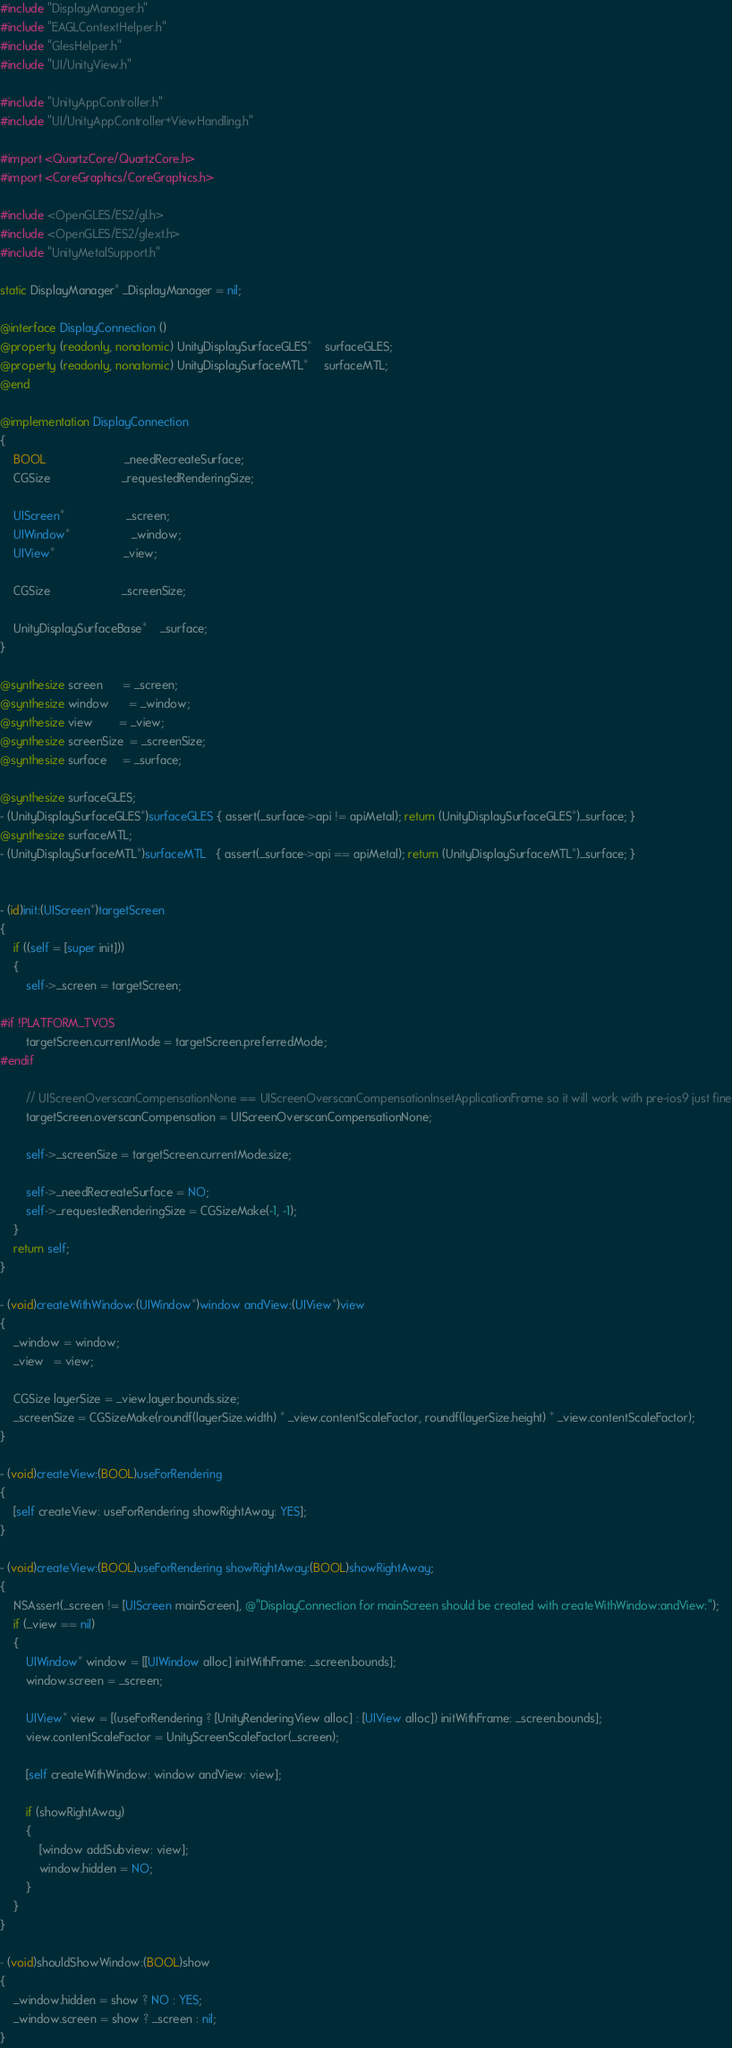<code> <loc_0><loc_0><loc_500><loc_500><_ObjectiveC_>#include "DisplayManager.h"
#include "EAGLContextHelper.h"
#include "GlesHelper.h"
#include "UI/UnityView.h"

#include "UnityAppController.h"
#include "UI/UnityAppController+ViewHandling.h"

#import <QuartzCore/QuartzCore.h>
#import <CoreGraphics/CoreGraphics.h>

#include <OpenGLES/ES2/gl.h>
#include <OpenGLES/ES2/glext.h>
#include "UnityMetalSupport.h"

static DisplayManager* _DisplayManager = nil;

@interface DisplayConnection ()
@property (readonly, nonatomic) UnityDisplaySurfaceGLES*    surfaceGLES;
@property (readonly, nonatomic) UnityDisplaySurfaceMTL*     surfaceMTL;
@end

@implementation DisplayConnection
{
    BOOL                        _needRecreateSurface;
    CGSize                      _requestedRenderingSize;

    UIScreen*                   _screen;
    UIWindow*                   _window;
    UIView*                     _view;

    CGSize                      _screenSize;

    UnityDisplaySurfaceBase*    _surface;
}

@synthesize screen      = _screen;
@synthesize window      = _window;
@synthesize view        = _view;
@synthesize screenSize  = _screenSize;
@synthesize surface     = _surface;

@synthesize surfaceGLES;
- (UnityDisplaySurfaceGLES*)surfaceGLES { assert(_surface->api != apiMetal); return (UnityDisplaySurfaceGLES*)_surface; }
@synthesize surfaceMTL;
- (UnityDisplaySurfaceMTL*)surfaceMTL   { assert(_surface->api == apiMetal); return (UnityDisplaySurfaceMTL*)_surface; }


- (id)init:(UIScreen*)targetScreen
{
    if ((self = [super init]))
    {
        self->_screen = targetScreen;

#if !PLATFORM_TVOS
        targetScreen.currentMode = targetScreen.preferredMode;
#endif

        // UIScreenOverscanCompensationNone == UIScreenOverscanCompensationInsetApplicationFrame so it will work with pre-ios9 just fine
        targetScreen.overscanCompensation = UIScreenOverscanCompensationNone;

        self->_screenSize = targetScreen.currentMode.size;

        self->_needRecreateSurface = NO;
        self->_requestedRenderingSize = CGSizeMake(-1, -1);
    }
    return self;
}

- (void)createWithWindow:(UIWindow*)window andView:(UIView*)view
{
    _window = window;
    _view   = view;

    CGSize layerSize = _view.layer.bounds.size;
    _screenSize = CGSizeMake(roundf(layerSize.width) * _view.contentScaleFactor, roundf(layerSize.height) * _view.contentScaleFactor);
}

- (void)createView:(BOOL)useForRendering
{
    [self createView: useForRendering showRightAway: YES];
}

- (void)createView:(BOOL)useForRendering showRightAway:(BOOL)showRightAway;
{
    NSAssert(_screen != [UIScreen mainScreen], @"DisplayConnection for mainScreen should be created with createWithWindow:andView:");
    if (_view == nil)
    {
        UIWindow* window = [[UIWindow alloc] initWithFrame: _screen.bounds];
        window.screen = _screen;

        UIView* view = [(useForRendering ? [UnityRenderingView alloc] : [UIView alloc]) initWithFrame: _screen.bounds];
        view.contentScaleFactor = UnityScreenScaleFactor(_screen);

        [self createWithWindow: window andView: view];

        if (showRightAway)
        {
            [window addSubview: view];
            window.hidden = NO;
        }
    }
}

- (void)shouldShowWindow:(BOOL)show
{
    _window.hidden = show ? NO : YES;
    _window.screen = show ? _screen : nil;
}
</code> 